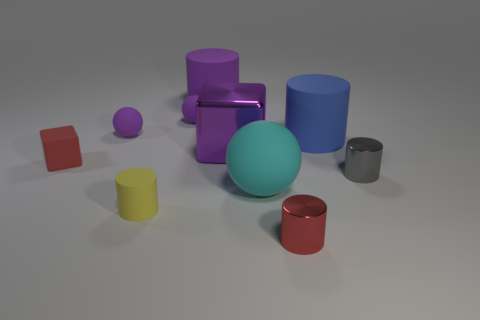Do the red thing in front of the tiny gray object and the tiny gray thing have the same material?
Give a very brief answer. Yes. There is a gray shiny object; what shape is it?
Your answer should be compact. Cylinder. How many yellow objects are in front of the purple cube that is in front of the matte cylinder that is right of the big metallic cube?
Provide a succinct answer. 1. How many other things are made of the same material as the tiny red cube?
Your response must be concise. 6. There is a red cylinder that is the same size as the gray thing; what is it made of?
Offer a very short reply. Metal. There is a big matte cylinder left of the red metallic cylinder; is it the same color as the metallic object left of the red shiny cylinder?
Make the answer very short. Yes. Is there a cyan rubber object of the same shape as the tiny yellow rubber thing?
Provide a short and direct response. No. There is a gray object that is the same size as the red block; what shape is it?
Provide a succinct answer. Cylinder. How many tiny matte cubes have the same color as the big block?
Give a very brief answer. 0. There is a metallic cylinder that is in front of the big cyan rubber sphere; what size is it?
Make the answer very short. Small. 